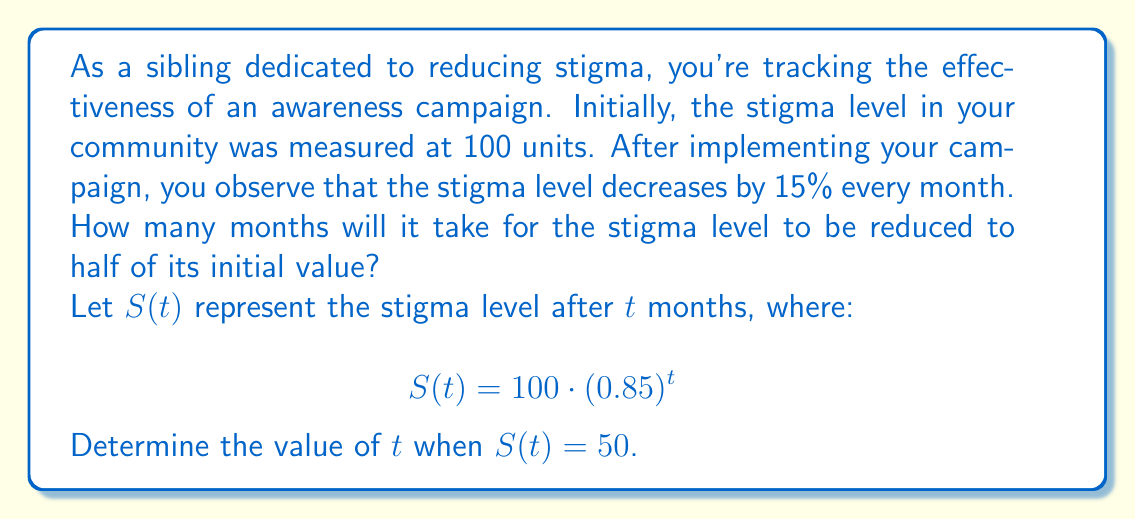Give your solution to this math problem. To solve this problem, we need to use the exponential decay formula and solve for $t$. Here's the step-by-step process:

1) We start with the equation:
   $$S(t) = 100 \cdot (0.85)^t$$

2) We want to find $t$ when $S(t) = 50$, so we substitute this:
   $$50 = 100 \cdot (0.85)^t$$

3) Divide both sides by 100:
   $$0.5 = (0.85)^t$$

4) To solve for $t$, we need to take the logarithm of both sides. We can use any base, but natural log (ln) is often convenient:
   $$\ln(0.5) = \ln((0.85)^t)$$

5) Using the logarithm property $\ln(a^b) = b\ln(a)$, we get:
   $$\ln(0.5) = t \cdot \ln(0.85)$$

6) Now we can solve for $t$:
   $$t = \frac{\ln(0.5)}{\ln(0.85)}$$

7) Using a calculator or computer:
   $$t \approx 4.27$$

8) Since we can't have a fractional month in this context, we round up to the nearest whole month.
Answer: It will take 5 months for the stigma level to be reduced to half of its initial value. 